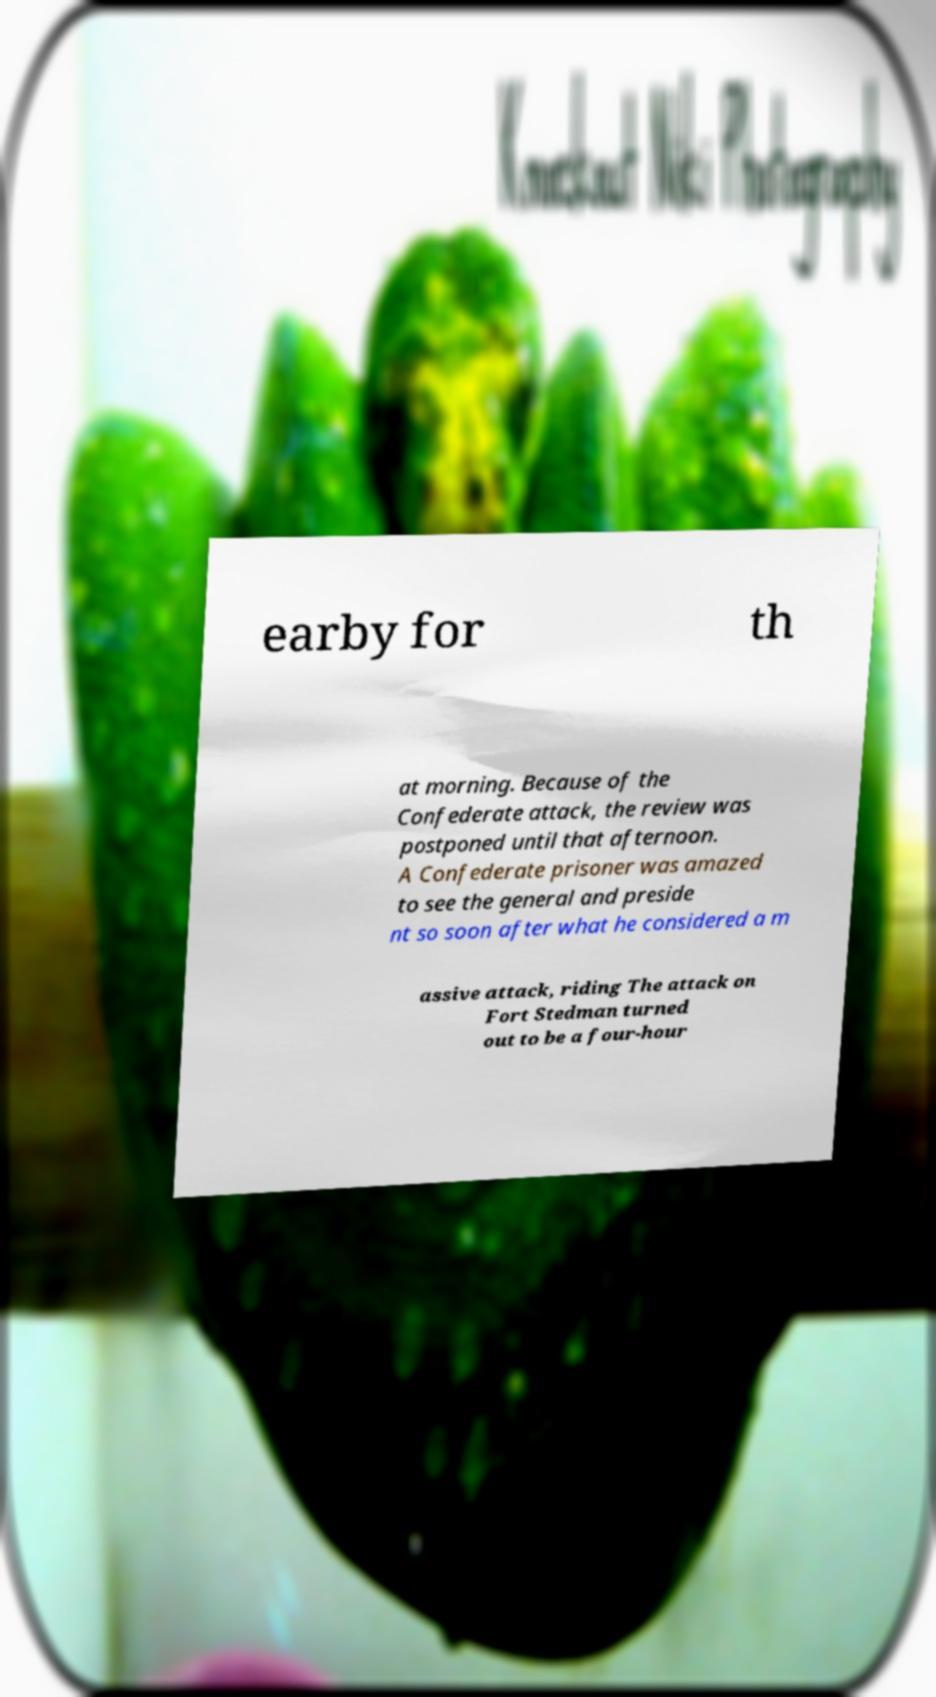Could you assist in decoding the text presented in this image and type it out clearly? earby for th at morning. Because of the Confederate attack, the review was postponed until that afternoon. A Confederate prisoner was amazed to see the general and preside nt so soon after what he considered a m assive attack, riding The attack on Fort Stedman turned out to be a four-hour 